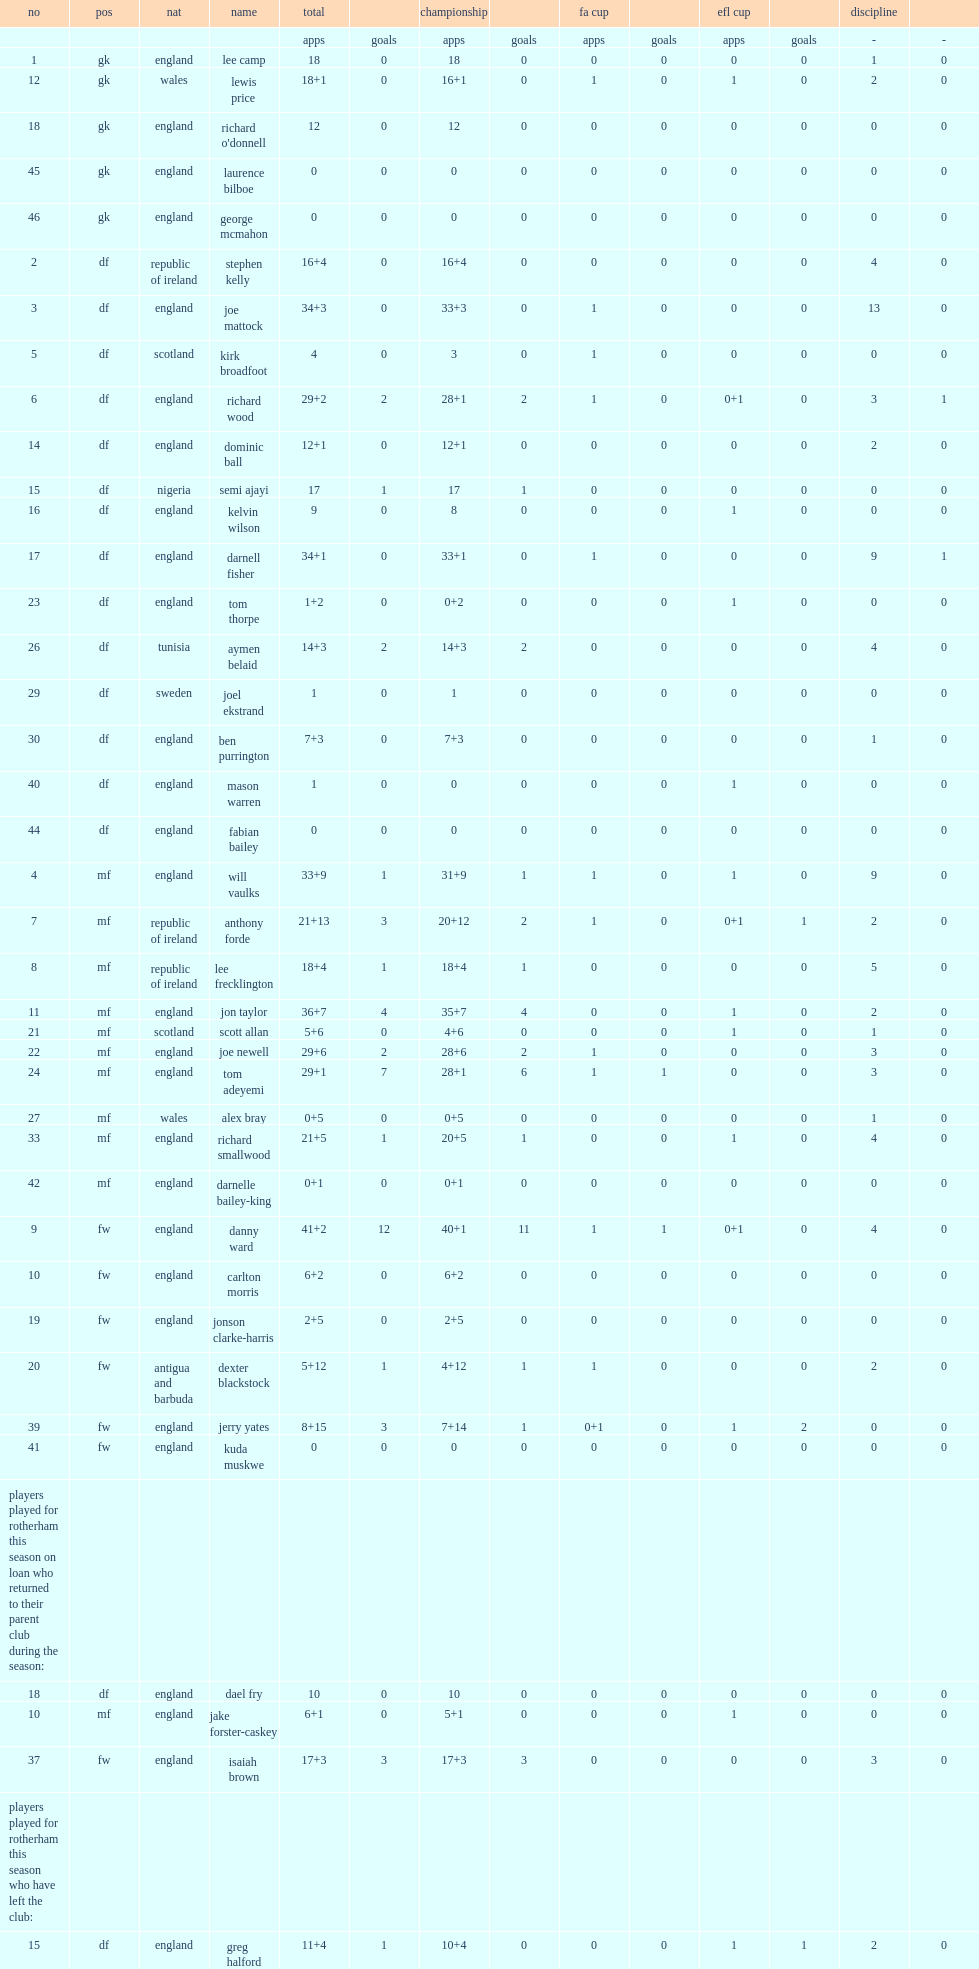Except for competing in the championship, what cups did rotherham united f.c. also participate in? Fa cup efl cup. 